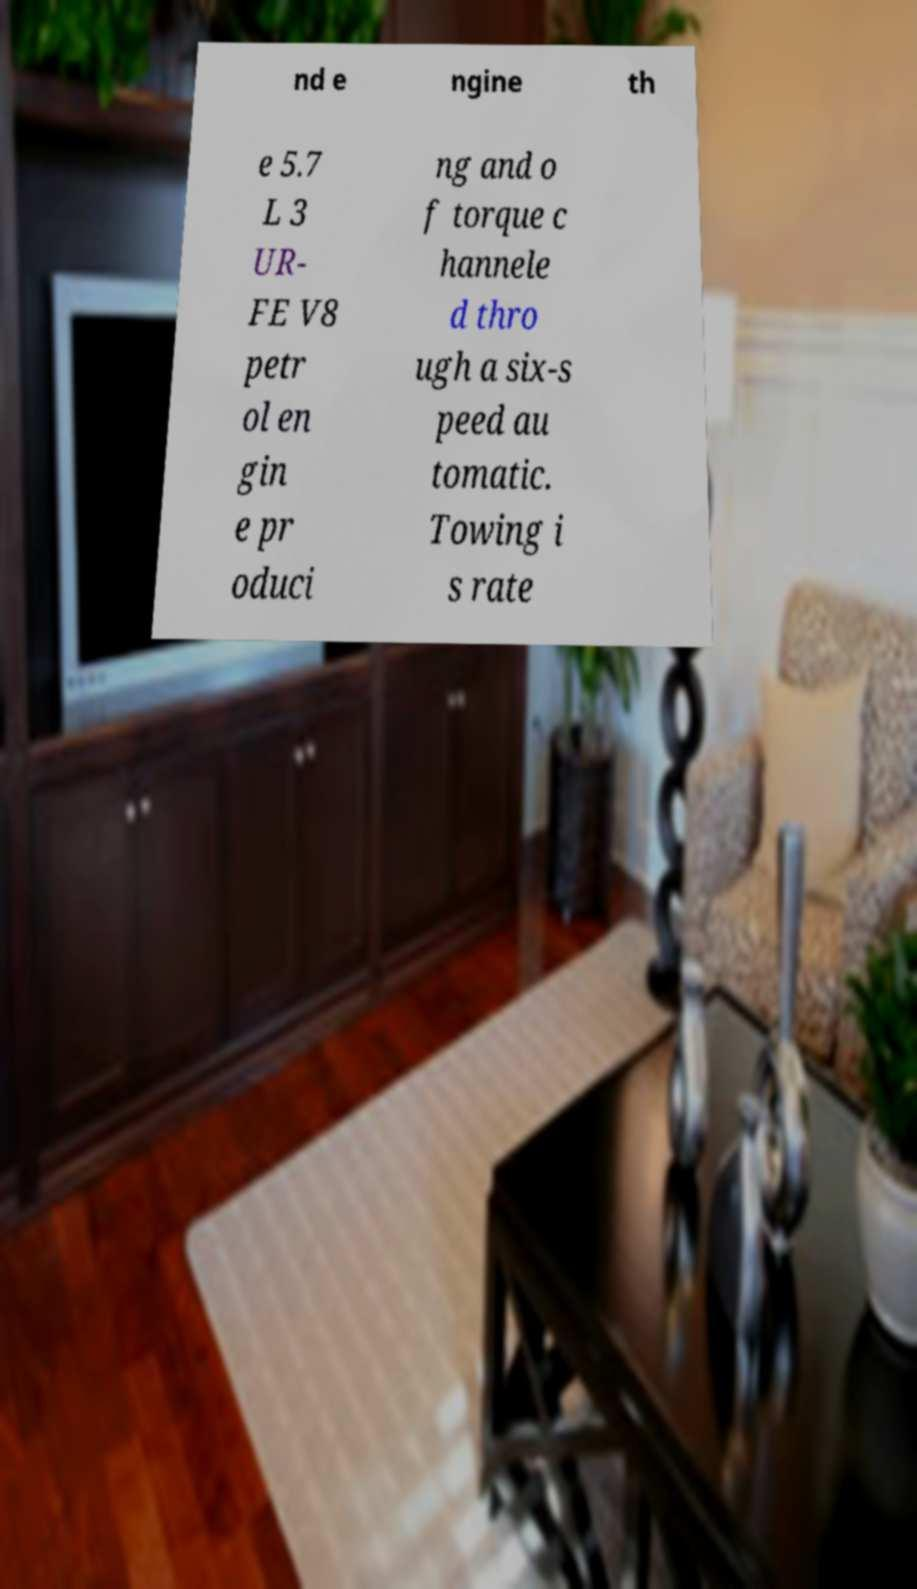I need the written content from this picture converted into text. Can you do that? nd e ngine th e 5.7 L 3 UR- FE V8 petr ol en gin e pr oduci ng and o f torque c hannele d thro ugh a six-s peed au tomatic. Towing i s rate 